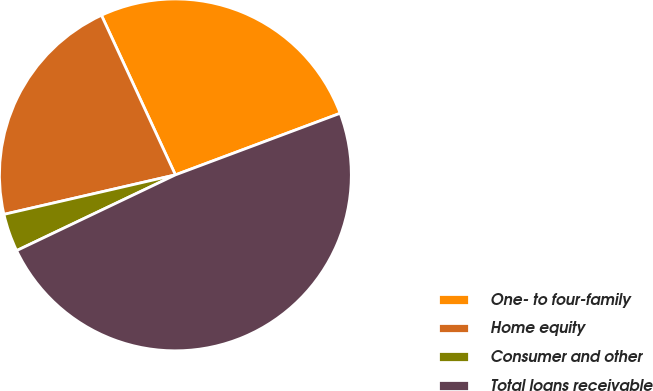Convert chart. <chart><loc_0><loc_0><loc_500><loc_500><pie_chart><fcel>One- to four-family<fcel>Home equity<fcel>Consumer and other<fcel>Total loans receivable<nl><fcel>26.21%<fcel>21.7%<fcel>3.48%<fcel>48.61%<nl></chart> 